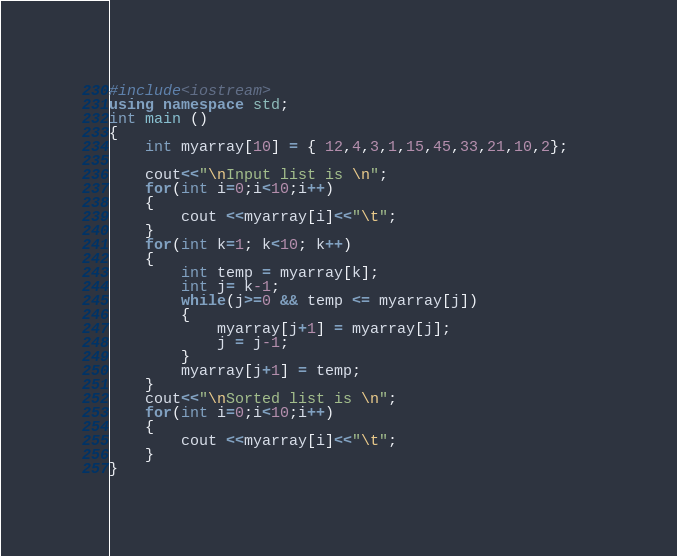Convert code to text. <code><loc_0><loc_0><loc_500><loc_500><_C++_>#include<iostream>  
using namespace std;  
int main ()  
{    
    int myarray[10] = { 12,4,3,1,15,45,33,21,10,2};   
       
    cout<<"\nInput list is \n";
    for(int i=0;i<10;i++)  
    {  
        cout <<myarray[i]<<"\t";  
    }    
    for(int k=1; k<10; k++)   
    {  
        int temp = myarray[k];  
        int j= k-1;  
        while(j>=0 && temp <= myarray[j])  
        {  
            myarray[j+1] = myarray[j];   
            j = j-1;  
        }  
        myarray[j+1] = temp;  
    }  
    cout<<"\nSorted list is \n";
    for(int i=0;i<10;i++)  
    {  
        cout <<myarray[i]<<"\t";  
    }  
}
</code> 